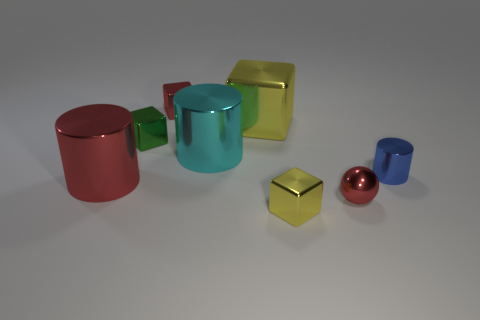What number of objects are small red objects in front of the tiny green metal cube or purple objects?
Offer a very short reply. 1. The small shiny cylinder is what color?
Offer a very short reply. Blue. There is a small red object right of the big yellow shiny thing; what is its material?
Make the answer very short. Metal. There is a small yellow metallic object; is its shape the same as the large thing that is in front of the tiny blue metallic cylinder?
Offer a very short reply. No. Are there more brown shiny cylinders than tiny blue metallic objects?
Provide a short and direct response. No. Are there any other things that are the same color as the small metal cylinder?
Your answer should be compact. No. The green object that is made of the same material as the small red block is what shape?
Give a very brief answer. Cube. What material is the tiny thing to the left of the red metallic thing behind the blue metallic cylinder?
Your response must be concise. Metal. Do the yellow object in front of the red cylinder and the tiny green thing have the same shape?
Offer a very short reply. Yes. Is the number of small yellow blocks that are on the left side of the red block greater than the number of big yellow objects?
Your answer should be compact. No. 